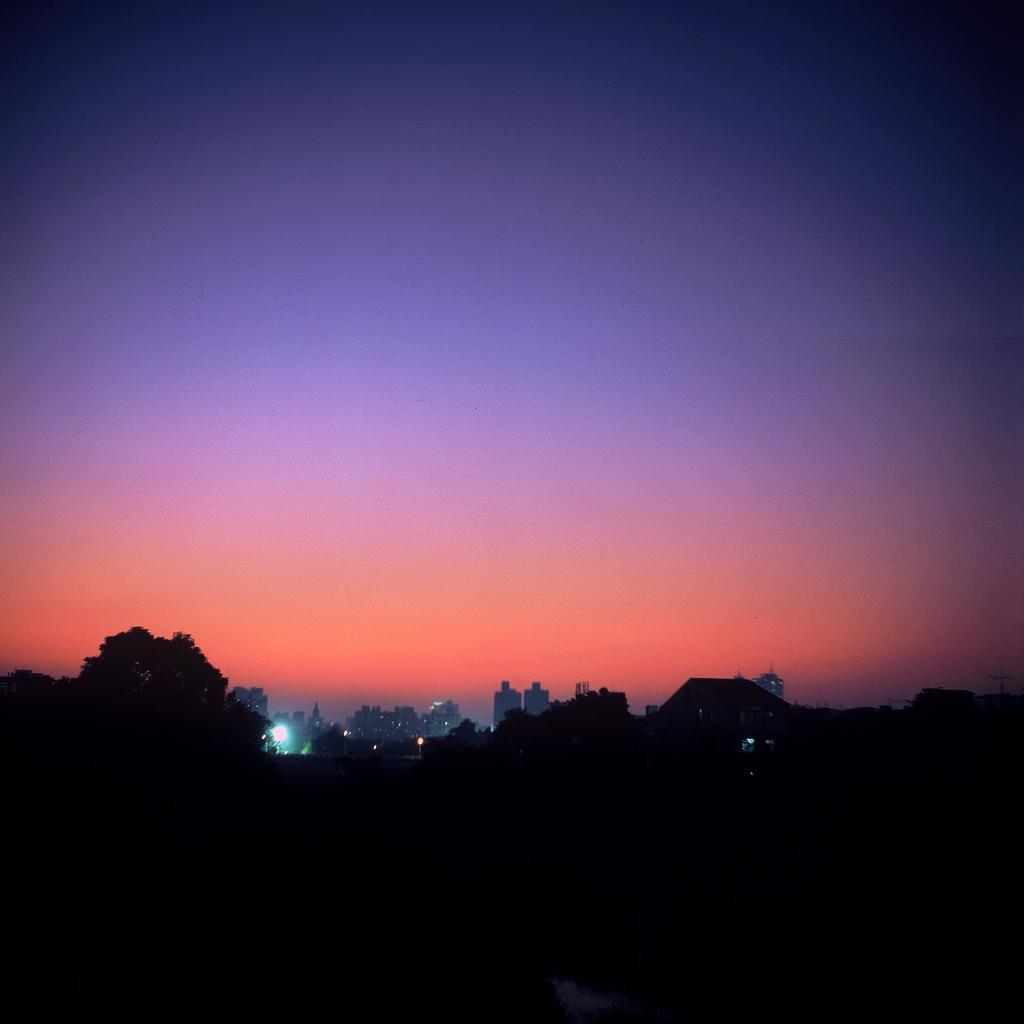What type of structures are present in the image? There are buildings in the image. What can be seen in front of the buildings? There are trees in front of the buildings. How would you describe the lighting in the image? The image appears to be a bit dark. What is visible at the top of the image? The sky is visible at the top of the image. Can you see any ants crawling on the buildings in the image? There are no ants visible in the image; the focus is on the buildings, trees, and sky. 